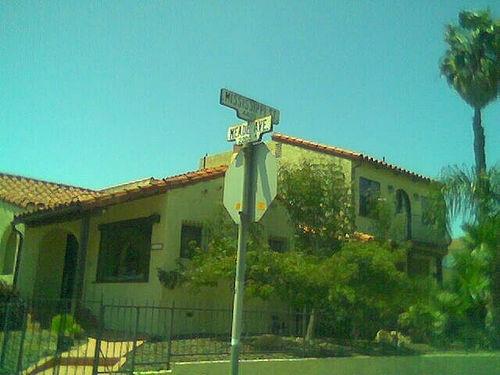What color is the roof?
Concise answer only. Orange. What are the cross streets?
Quick response, please. Mississippi and meade. Is the house abandoned?
Give a very brief answer. No. 